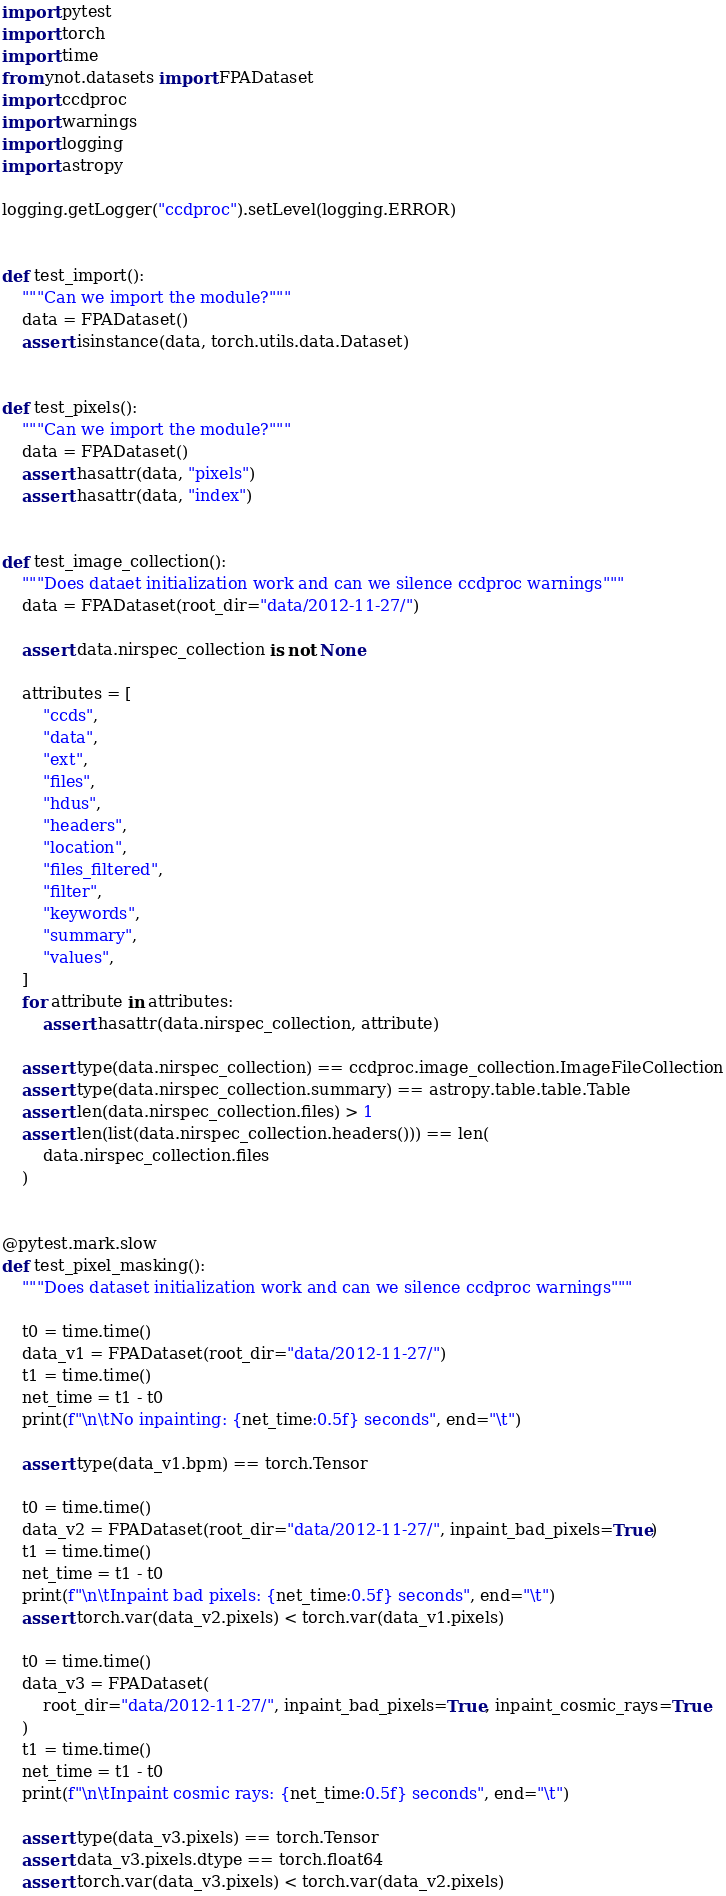Convert code to text. <code><loc_0><loc_0><loc_500><loc_500><_Python_>import pytest
import torch
import time
from ynot.datasets import FPADataset
import ccdproc
import warnings
import logging
import astropy

logging.getLogger("ccdproc").setLevel(logging.ERROR)


def test_import():
    """Can we import the module?"""
    data = FPADataset()
    assert isinstance(data, torch.utils.data.Dataset)


def test_pixels():
    """Can we import the module?"""
    data = FPADataset()
    assert hasattr(data, "pixels")
    assert hasattr(data, "index")


def test_image_collection():
    """Does dataet initialization work and can we silence ccdproc warnings"""
    data = FPADataset(root_dir="data/2012-11-27/")

    assert data.nirspec_collection is not None

    attributes = [
        "ccds",
        "data",
        "ext",
        "files",
        "hdus",
        "headers",
        "location",
        "files_filtered",
        "filter",
        "keywords",
        "summary",
        "values",
    ]
    for attribute in attributes:
        assert hasattr(data.nirspec_collection, attribute)

    assert type(data.nirspec_collection) == ccdproc.image_collection.ImageFileCollection
    assert type(data.nirspec_collection.summary) == astropy.table.table.Table
    assert len(data.nirspec_collection.files) > 1
    assert len(list(data.nirspec_collection.headers())) == len(
        data.nirspec_collection.files
    )


@pytest.mark.slow
def test_pixel_masking():
    """Does dataset initialization work and can we silence ccdproc warnings"""

    t0 = time.time()
    data_v1 = FPADataset(root_dir="data/2012-11-27/")
    t1 = time.time()
    net_time = t1 - t0
    print(f"\n\tNo inpainting: {net_time:0.5f} seconds", end="\t")

    assert type(data_v1.bpm) == torch.Tensor

    t0 = time.time()
    data_v2 = FPADataset(root_dir="data/2012-11-27/", inpaint_bad_pixels=True)
    t1 = time.time()
    net_time = t1 - t0
    print(f"\n\tInpaint bad pixels: {net_time:0.5f} seconds", end="\t")
    assert torch.var(data_v2.pixels) < torch.var(data_v1.pixels)

    t0 = time.time()
    data_v3 = FPADataset(
        root_dir="data/2012-11-27/", inpaint_bad_pixels=True, inpaint_cosmic_rays=True
    )
    t1 = time.time()
    net_time = t1 - t0
    print(f"\n\tInpaint cosmic rays: {net_time:0.5f} seconds", end="\t")

    assert type(data_v3.pixels) == torch.Tensor
    assert data_v3.pixels.dtype == torch.float64
    assert torch.var(data_v3.pixels) < torch.var(data_v2.pixels)
</code> 